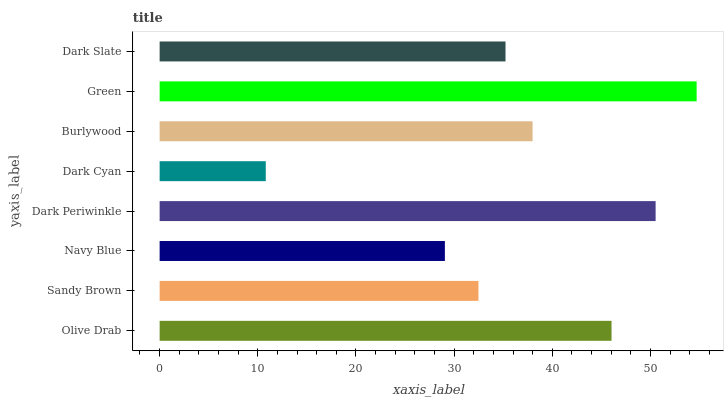Is Dark Cyan the minimum?
Answer yes or no. Yes. Is Green the maximum?
Answer yes or no. Yes. Is Sandy Brown the minimum?
Answer yes or no. No. Is Sandy Brown the maximum?
Answer yes or no. No. Is Olive Drab greater than Sandy Brown?
Answer yes or no. Yes. Is Sandy Brown less than Olive Drab?
Answer yes or no. Yes. Is Sandy Brown greater than Olive Drab?
Answer yes or no. No. Is Olive Drab less than Sandy Brown?
Answer yes or no. No. Is Burlywood the high median?
Answer yes or no. Yes. Is Dark Slate the low median?
Answer yes or no. Yes. Is Olive Drab the high median?
Answer yes or no. No. Is Sandy Brown the low median?
Answer yes or no. No. 